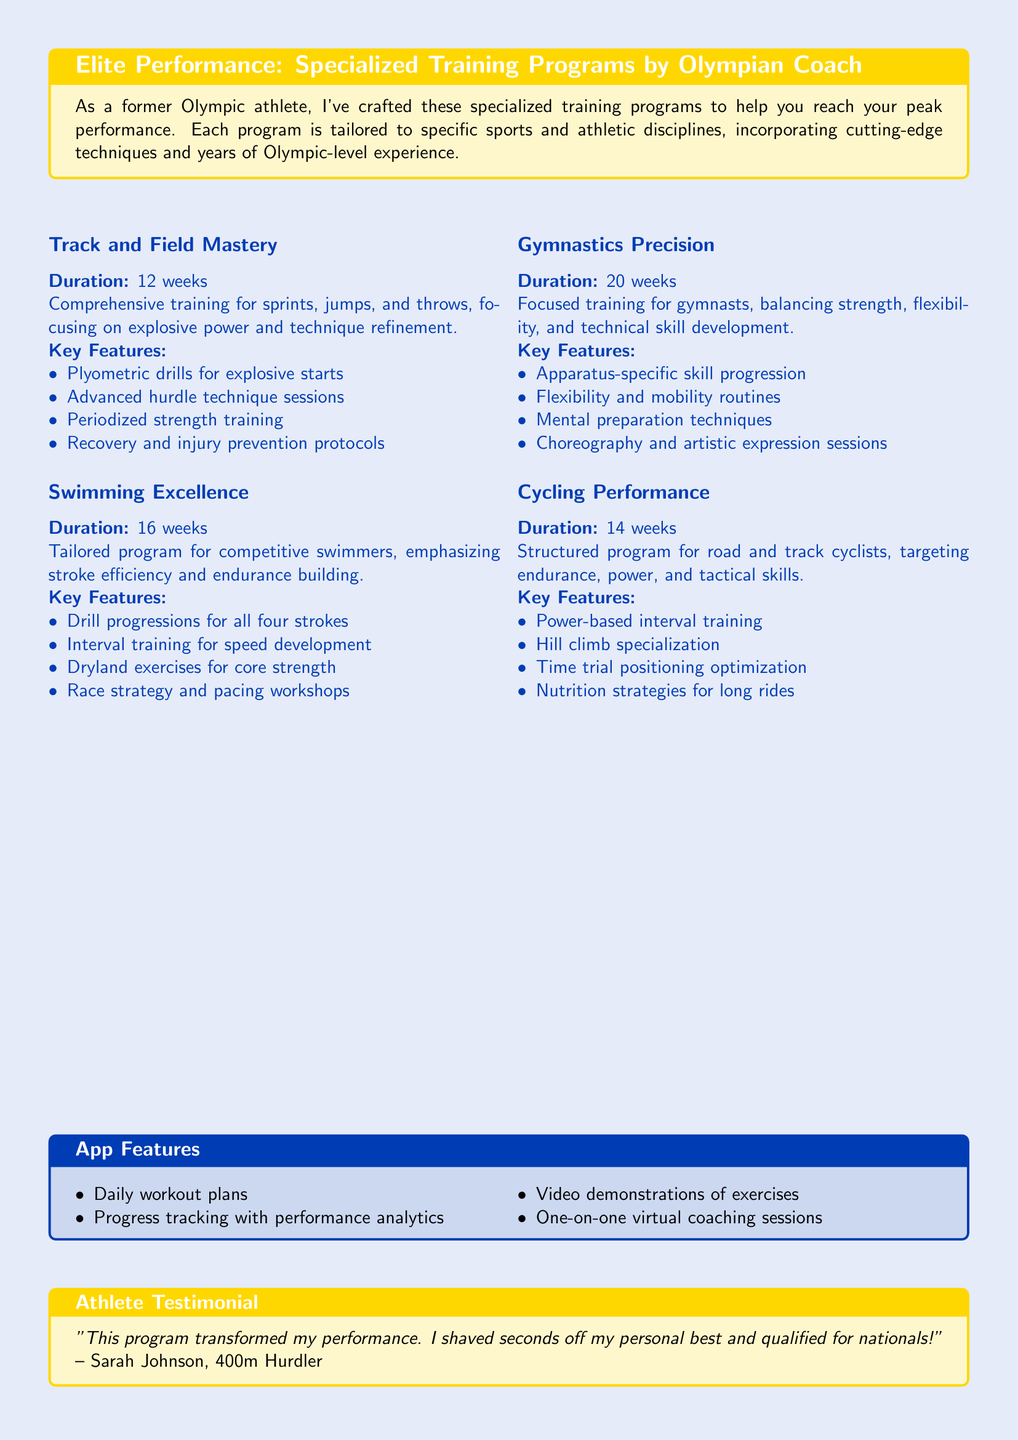What is the duration of the Track and Field Mastery program? The duration of the Track and Field Mastery program is specified in the document as 12 weeks.
Answer: 12 weeks What key feature is included in the Swimming Excellence program? One of the key features listed under Swimming Excellence includes "Drill progressions for all four strokes."
Answer: Drill progressions for all four strokes What is the main focus of the Gymnastics Precision program? The main focus of the Gymnastics Precision program is balancing strength, flexibility, and technical skill development.
Answer: Strength, flexibility, and technical skill development How many weeks is the Cycling Performance program? The document states that the Cycling Performance program lasts for 14 weeks.
Answer: 14 weeks Who is the athlete testimonial from? The athlete testimonial is credited to Sarah Johnson, who is identified as a 400m Hurdler.
Answer: Sarah Johnson What type of training does the Cycling Performance program include? The Cycling Performance program includes "Power-based interval training" as a key feature.
Answer: Power-based interval training What feature of the app allows for tracking progress? The document mentions "Progress tracking with performance analytics" as a feature of the app.
Answer: Progress tracking with performance analytics How many weeks does the Swimming Excellence program last? The Swimming Excellence program lasts for 16 weeks, as stated in the document.
Answer: 16 weeks 